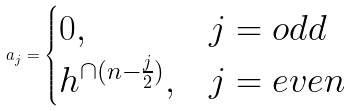Convert formula to latex. <formula><loc_0><loc_0><loc_500><loc_500>a _ { j } = \begin{cases} 0 , & j = o d d \\ h ^ { \cap ( n - \frac { j } { 2 } ) } , & j = e v e n \end{cases}</formula> 